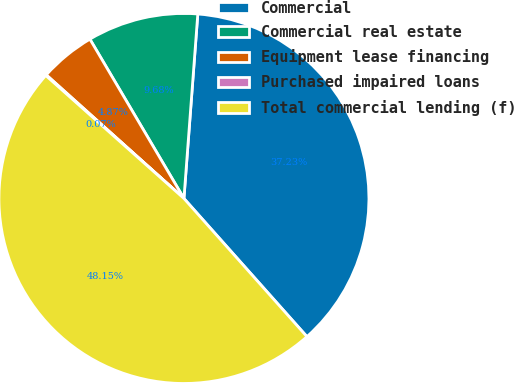Convert chart. <chart><loc_0><loc_0><loc_500><loc_500><pie_chart><fcel>Commercial<fcel>Commercial real estate<fcel>Equipment lease financing<fcel>Purchased impaired loans<fcel>Total commercial lending (f)<nl><fcel>37.23%<fcel>9.68%<fcel>4.87%<fcel>0.07%<fcel>48.15%<nl></chart> 